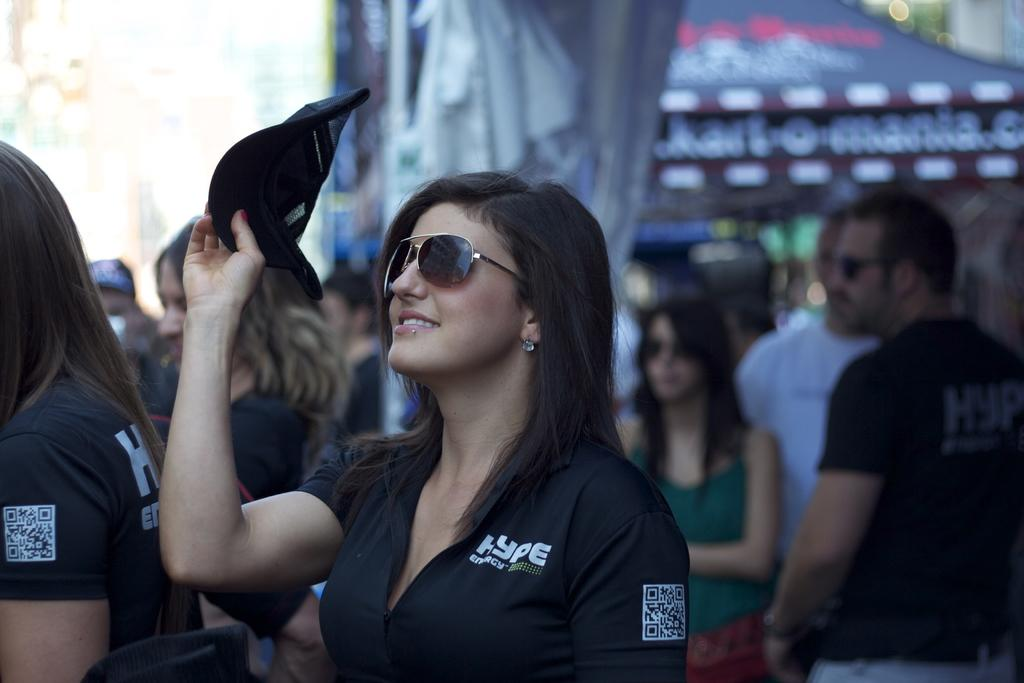How many people are in the image? There is a group of people in the image. Can you describe any specific features of one of the people in the group? A woman in the group is wearing goggles. What is the woman's expression in the image? The woman is smiling. How would you describe the background of the image? The background of the image is blurry. What type of pets are visible in the image? There are no pets visible in the image. What kind of fish can be seen swimming in the background? There is no body of water or fish present in the image. 